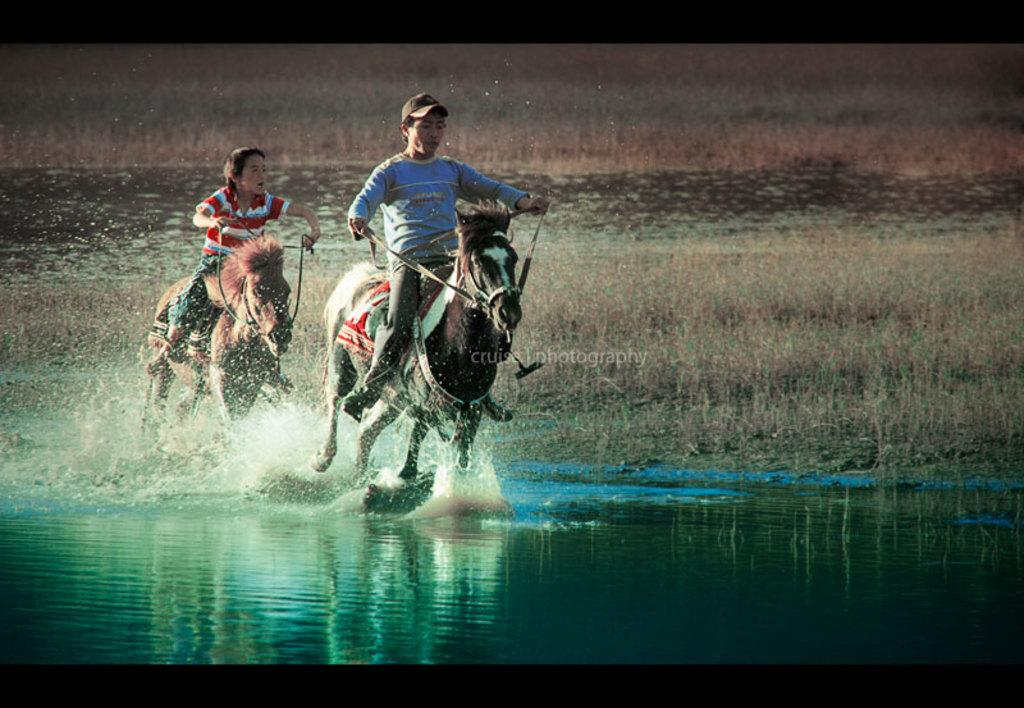How many people are in the image? There are two persons in the image. What are the persons doing in the image? The persons are riding horses. What type of clothing are the persons wearing on their heads? The persons are wearing caps. What type of clothing are the persons are the persons wearing on their upper bodies? The persons are wearing t-shirts. What can be seen in the background of the image? There is grass in the backdrop of the image. What type of scarf is the passenger wearing in the image? There is no passenger present in the image, and no one is wearing a scarf. 